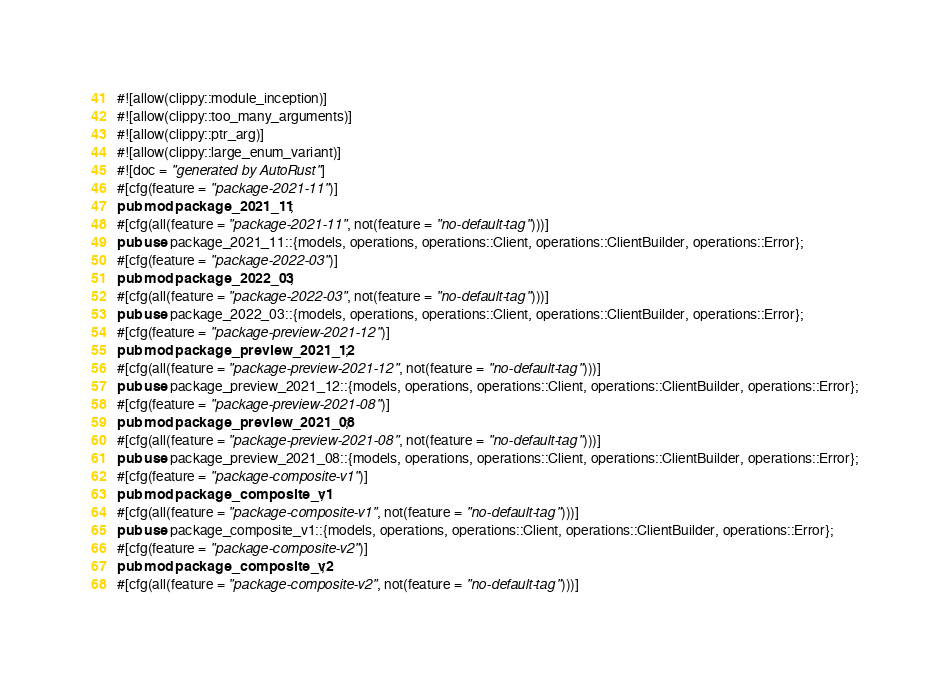Convert code to text. <code><loc_0><loc_0><loc_500><loc_500><_Rust_>#![allow(clippy::module_inception)]
#![allow(clippy::too_many_arguments)]
#![allow(clippy::ptr_arg)]
#![allow(clippy::large_enum_variant)]
#![doc = "generated by AutoRust"]
#[cfg(feature = "package-2021-11")]
pub mod package_2021_11;
#[cfg(all(feature = "package-2021-11", not(feature = "no-default-tag")))]
pub use package_2021_11::{models, operations, operations::Client, operations::ClientBuilder, operations::Error};
#[cfg(feature = "package-2022-03")]
pub mod package_2022_03;
#[cfg(all(feature = "package-2022-03", not(feature = "no-default-tag")))]
pub use package_2022_03::{models, operations, operations::Client, operations::ClientBuilder, operations::Error};
#[cfg(feature = "package-preview-2021-12")]
pub mod package_preview_2021_12;
#[cfg(all(feature = "package-preview-2021-12", not(feature = "no-default-tag")))]
pub use package_preview_2021_12::{models, operations, operations::Client, operations::ClientBuilder, operations::Error};
#[cfg(feature = "package-preview-2021-08")]
pub mod package_preview_2021_08;
#[cfg(all(feature = "package-preview-2021-08", not(feature = "no-default-tag")))]
pub use package_preview_2021_08::{models, operations, operations::Client, operations::ClientBuilder, operations::Error};
#[cfg(feature = "package-composite-v1")]
pub mod package_composite_v1;
#[cfg(all(feature = "package-composite-v1", not(feature = "no-default-tag")))]
pub use package_composite_v1::{models, operations, operations::Client, operations::ClientBuilder, operations::Error};
#[cfg(feature = "package-composite-v2")]
pub mod package_composite_v2;
#[cfg(all(feature = "package-composite-v2", not(feature = "no-default-tag")))]</code> 